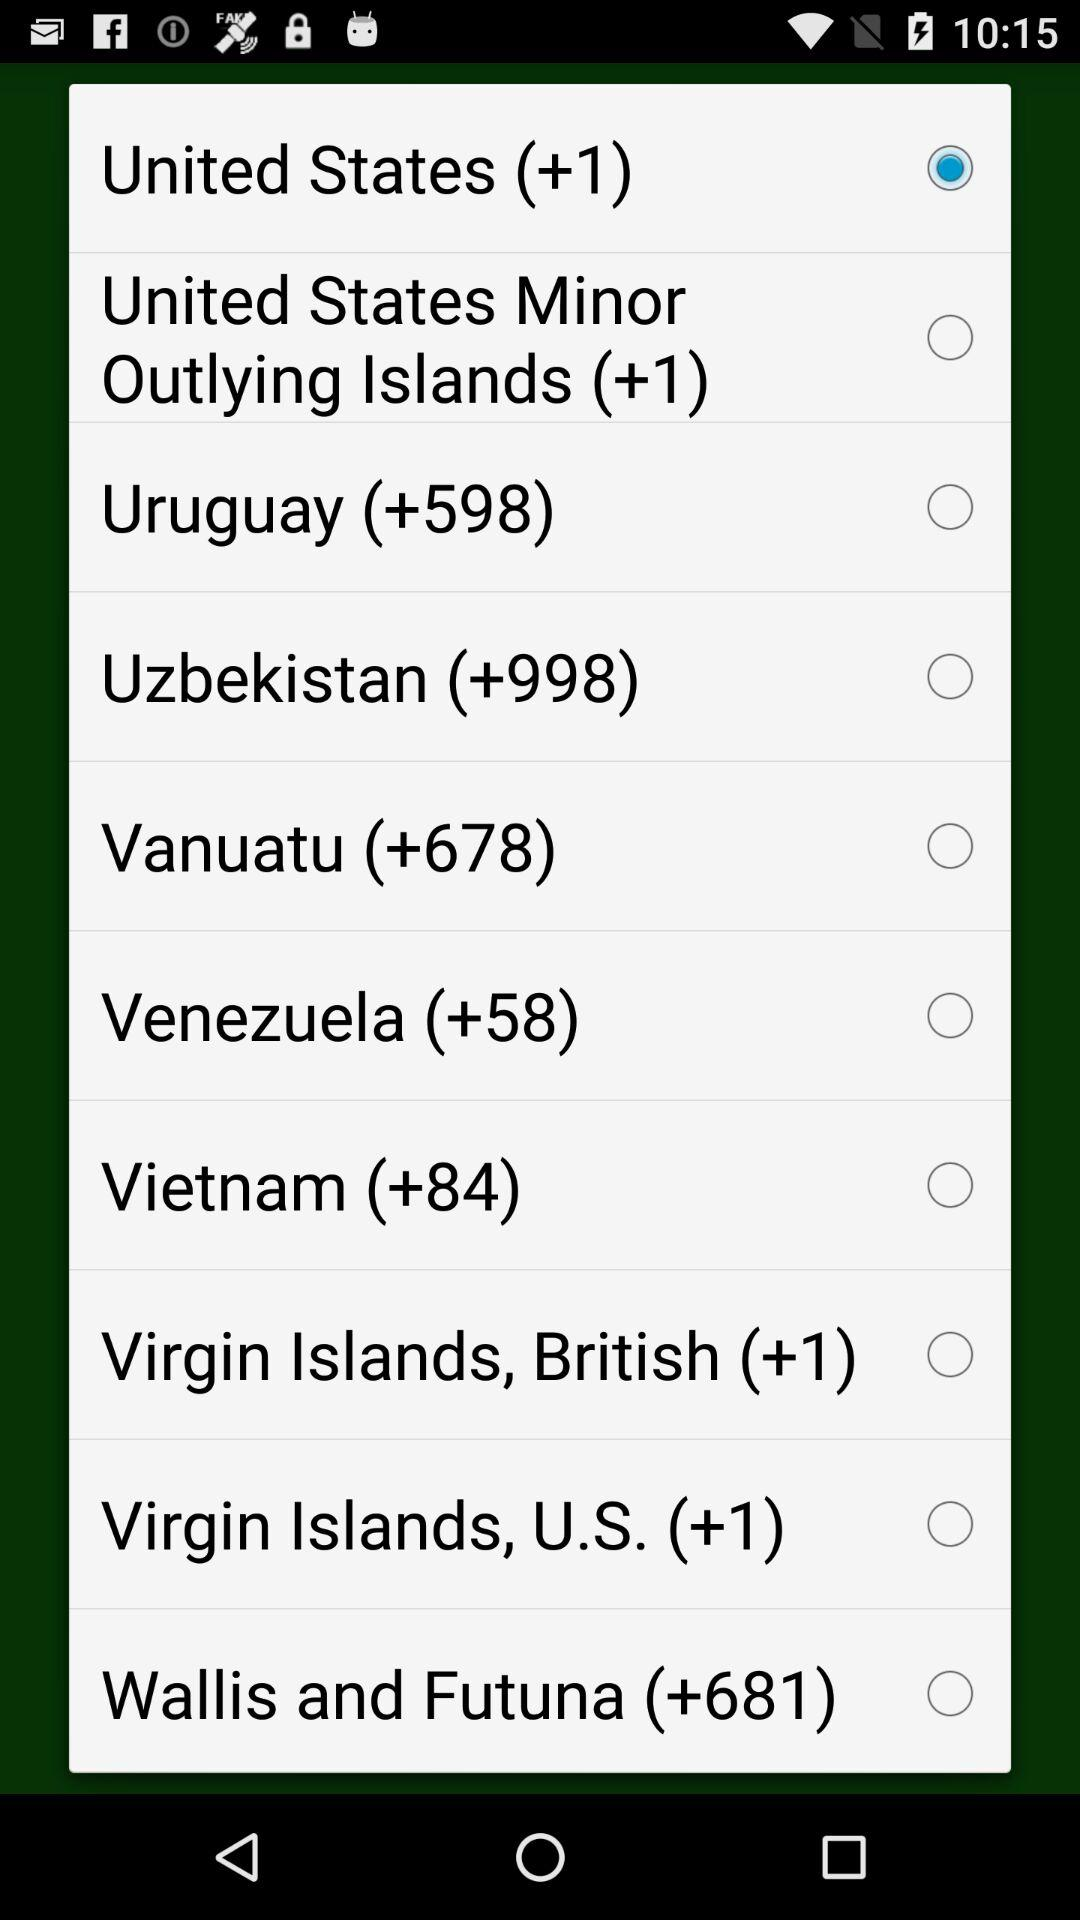Is "Vietnam (+84)" selected or not? "Vietnam (+84)" is not selected. 